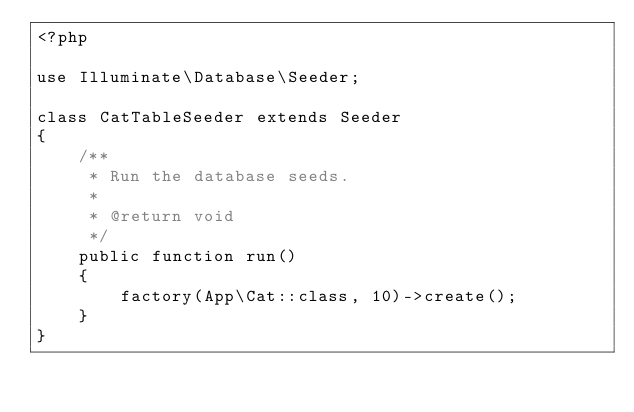Convert code to text. <code><loc_0><loc_0><loc_500><loc_500><_PHP_><?php

use Illuminate\Database\Seeder;

class CatTableSeeder extends Seeder
{
    /**
     * Run the database seeds.
     *
     * @return void
     */
    public function run()
    {
        factory(App\Cat::class, 10)->create();
    }
}
</code> 